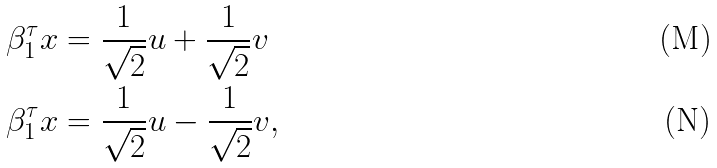<formula> <loc_0><loc_0><loc_500><loc_500>\beta _ { 1 } ^ { \tau } x & = \frac { 1 } { \sqrt { 2 } } u + \frac { 1 } { \sqrt { 2 } } v \\ \beta _ { 1 } ^ { \tau } x & = \frac { 1 } { \sqrt { 2 } } u - \frac { 1 } { \sqrt { 2 } } v ,</formula> 